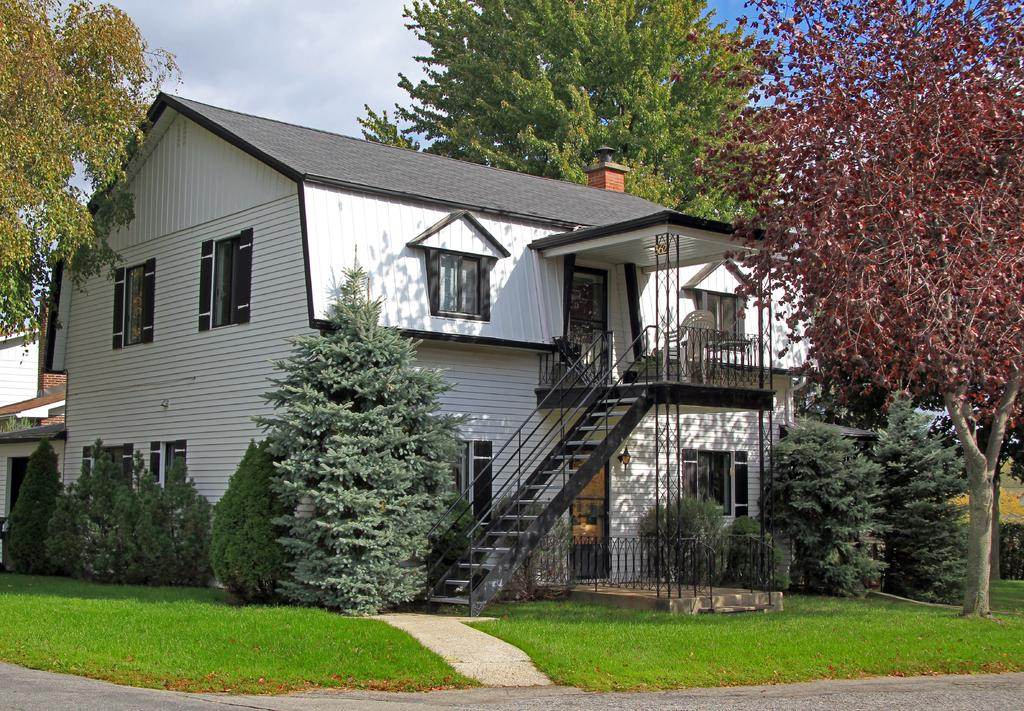What is the main structure in the center of the image? There is a building in the center of the image. What type of vegetation surrounds the building? There are trees around the building. What parts of the trees are visible in the image? Branches are visible in the image. What type of ground cover is present in the image? There is grass in the image. What is present in the foreground of the image? Dry leaves and a road are present in the foreground. What type of cloud can be seen in the image? There are no clouds visible in the image. What type of button is present on the tank in the image? There is no tank or button present in the image. 